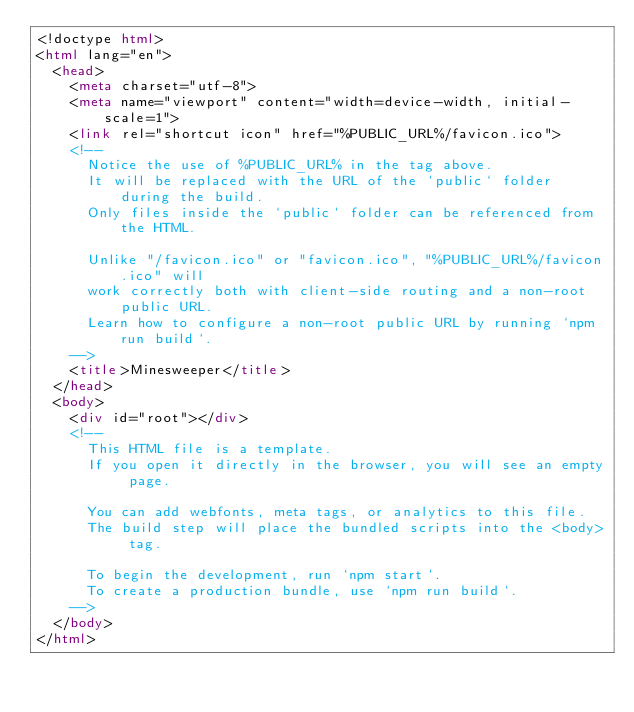<code> <loc_0><loc_0><loc_500><loc_500><_HTML_><!doctype html>
<html lang="en">
  <head>
    <meta charset="utf-8">
    <meta name="viewport" content="width=device-width, initial-scale=1">
    <link rel="shortcut icon" href="%PUBLIC_URL%/favicon.ico">
    <!--
      Notice the use of %PUBLIC_URL% in the tag above.
      It will be replaced with the URL of the `public` folder during the build.
      Only files inside the `public` folder can be referenced from the HTML.

      Unlike "/favicon.ico" or "favicon.ico", "%PUBLIC_URL%/favicon.ico" will
      work correctly both with client-side routing and a non-root public URL.
      Learn how to configure a non-root public URL by running `npm run build`.
    -->
    <title>Minesweeper</title>
  </head>
  <body>
    <div id="root"></div>
    <!--
      This HTML file is a template.
      If you open it directly in the browser, you will see an empty page.

      You can add webfonts, meta tags, or analytics to this file.
      The build step will place the bundled scripts into the <body> tag.

      To begin the development, run `npm start`.
      To create a production bundle, use `npm run build`.
    -->
  </body>
</html>
</code> 